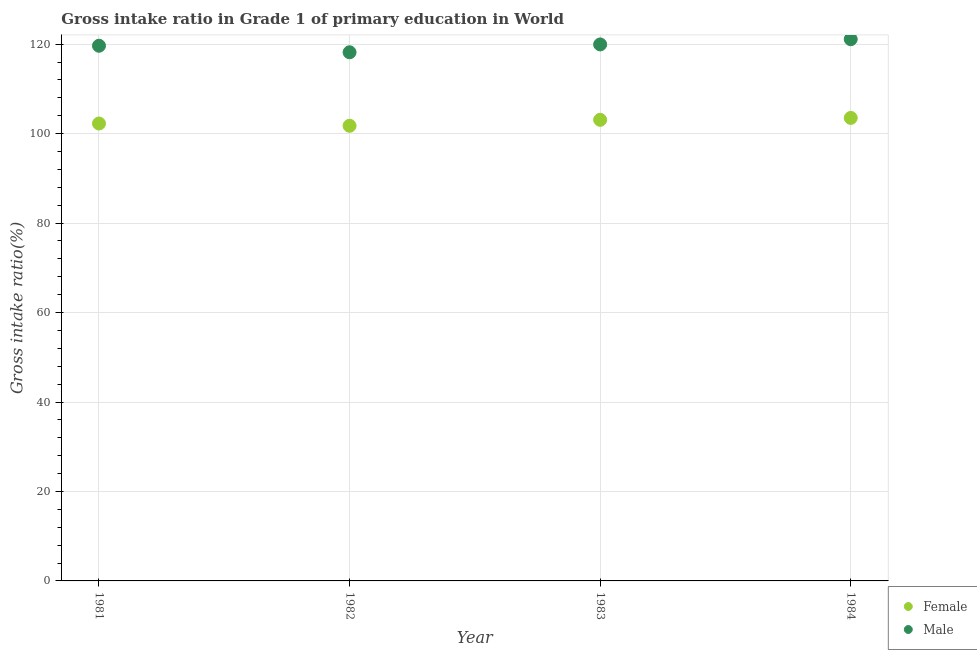Is the number of dotlines equal to the number of legend labels?
Offer a very short reply. Yes. What is the gross intake ratio(male) in 1983?
Your answer should be compact. 119.94. Across all years, what is the maximum gross intake ratio(female)?
Your response must be concise. 103.51. Across all years, what is the minimum gross intake ratio(male)?
Offer a very short reply. 118.19. In which year was the gross intake ratio(female) maximum?
Keep it short and to the point. 1984. What is the total gross intake ratio(male) in the graph?
Make the answer very short. 478.88. What is the difference between the gross intake ratio(female) in 1981 and that in 1983?
Your response must be concise. -0.82. What is the difference between the gross intake ratio(female) in 1983 and the gross intake ratio(male) in 1984?
Offer a terse response. -18.02. What is the average gross intake ratio(female) per year?
Provide a short and direct response. 102.65. In the year 1984, what is the difference between the gross intake ratio(male) and gross intake ratio(female)?
Ensure brevity in your answer.  17.6. In how many years, is the gross intake ratio(male) greater than 100 %?
Your response must be concise. 4. What is the ratio of the gross intake ratio(female) in 1983 to that in 1984?
Give a very brief answer. 1. Is the difference between the gross intake ratio(male) in 1982 and 1984 greater than the difference between the gross intake ratio(female) in 1982 and 1984?
Give a very brief answer. No. What is the difference between the highest and the second highest gross intake ratio(female)?
Make the answer very short. 0.43. What is the difference between the highest and the lowest gross intake ratio(male)?
Ensure brevity in your answer.  2.92. Is the sum of the gross intake ratio(female) in 1982 and 1983 greater than the maximum gross intake ratio(male) across all years?
Keep it short and to the point. Yes. Does the gross intake ratio(male) monotonically increase over the years?
Provide a succinct answer. No. Is the gross intake ratio(male) strictly greater than the gross intake ratio(female) over the years?
Your response must be concise. Yes. Are the values on the major ticks of Y-axis written in scientific E-notation?
Your response must be concise. No. Does the graph contain any zero values?
Offer a terse response. No. Where does the legend appear in the graph?
Offer a very short reply. Bottom right. How many legend labels are there?
Your response must be concise. 2. What is the title of the graph?
Offer a terse response. Gross intake ratio in Grade 1 of primary education in World. Does "Female population" appear as one of the legend labels in the graph?
Give a very brief answer. No. What is the label or title of the Y-axis?
Make the answer very short. Gross intake ratio(%). What is the Gross intake ratio(%) in Female in 1981?
Your response must be concise. 102.26. What is the Gross intake ratio(%) of Male in 1981?
Make the answer very short. 119.65. What is the Gross intake ratio(%) of Female in 1982?
Offer a very short reply. 101.75. What is the Gross intake ratio(%) of Male in 1982?
Provide a short and direct response. 118.19. What is the Gross intake ratio(%) in Female in 1983?
Your response must be concise. 103.09. What is the Gross intake ratio(%) in Male in 1983?
Offer a terse response. 119.94. What is the Gross intake ratio(%) in Female in 1984?
Make the answer very short. 103.51. What is the Gross intake ratio(%) in Male in 1984?
Give a very brief answer. 121.11. Across all years, what is the maximum Gross intake ratio(%) in Female?
Your answer should be compact. 103.51. Across all years, what is the maximum Gross intake ratio(%) in Male?
Your answer should be very brief. 121.11. Across all years, what is the minimum Gross intake ratio(%) of Female?
Provide a short and direct response. 101.75. Across all years, what is the minimum Gross intake ratio(%) in Male?
Provide a short and direct response. 118.19. What is the total Gross intake ratio(%) of Female in the graph?
Ensure brevity in your answer.  410.61. What is the total Gross intake ratio(%) of Male in the graph?
Give a very brief answer. 478.88. What is the difference between the Gross intake ratio(%) in Female in 1981 and that in 1982?
Give a very brief answer. 0.51. What is the difference between the Gross intake ratio(%) in Male in 1981 and that in 1982?
Give a very brief answer. 1.46. What is the difference between the Gross intake ratio(%) of Female in 1981 and that in 1983?
Offer a terse response. -0.82. What is the difference between the Gross intake ratio(%) of Male in 1981 and that in 1983?
Make the answer very short. -0.3. What is the difference between the Gross intake ratio(%) of Female in 1981 and that in 1984?
Offer a very short reply. -1.25. What is the difference between the Gross intake ratio(%) of Male in 1981 and that in 1984?
Offer a terse response. -1.46. What is the difference between the Gross intake ratio(%) of Female in 1982 and that in 1983?
Your answer should be compact. -1.33. What is the difference between the Gross intake ratio(%) of Male in 1982 and that in 1983?
Keep it short and to the point. -1.75. What is the difference between the Gross intake ratio(%) in Female in 1982 and that in 1984?
Your response must be concise. -1.76. What is the difference between the Gross intake ratio(%) of Male in 1982 and that in 1984?
Make the answer very short. -2.92. What is the difference between the Gross intake ratio(%) in Female in 1983 and that in 1984?
Give a very brief answer. -0.43. What is the difference between the Gross intake ratio(%) of Male in 1983 and that in 1984?
Provide a succinct answer. -1.17. What is the difference between the Gross intake ratio(%) in Female in 1981 and the Gross intake ratio(%) in Male in 1982?
Your response must be concise. -15.93. What is the difference between the Gross intake ratio(%) of Female in 1981 and the Gross intake ratio(%) of Male in 1983?
Offer a very short reply. -17.68. What is the difference between the Gross intake ratio(%) in Female in 1981 and the Gross intake ratio(%) in Male in 1984?
Give a very brief answer. -18.85. What is the difference between the Gross intake ratio(%) of Female in 1982 and the Gross intake ratio(%) of Male in 1983?
Give a very brief answer. -18.19. What is the difference between the Gross intake ratio(%) of Female in 1982 and the Gross intake ratio(%) of Male in 1984?
Offer a terse response. -19.36. What is the difference between the Gross intake ratio(%) of Female in 1983 and the Gross intake ratio(%) of Male in 1984?
Your response must be concise. -18.02. What is the average Gross intake ratio(%) in Female per year?
Provide a succinct answer. 102.65. What is the average Gross intake ratio(%) in Male per year?
Offer a very short reply. 119.72. In the year 1981, what is the difference between the Gross intake ratio(%) in Female and Gross intake ratio(%) in Male?
Offer a very short reply. -17.38. In the year 1982, what is the difference between the Gross intake ratio(%) of Female and Gross intake ratio(%) of Male?
Provide a short and direct response. -16.44. In the year 1983, what is the difference between the Gross intake ratio(%) of Female and Gross intake ratio(%) of Male?
Your response must be concise. -16.86. In the year 1984, what is the difference between the Gross intake ratio(%) of Female and Gross intake ratio(%) of Male?
Give a very brief answer. -17.6. What is the ratio of the Gross intake ratio(%) of Male in 1981 to that in 1982?
Provide a succinct answer. 1.01. What is the ratio of the Gross intake ratio(%) of Male in 1981 to that in 1983?
Ensure brevity in your answer.  1. What is the ratio of the Gross intake ratio(%) of Female in 1981 to that in 1984?
Your answer should be compact. 0.99. What is the ratio of the Gross intake ratio(%) of Male in 1981 to that in 1984?
Offer a very short reply. 0.99. What is the ratio of the Gross intake ratio(%) in Female in 1982 to that in 1983?
Keep it short and to the point. 0.99. What is the ratio of the Gross intake ratio(%) in Male in 1982 to that in 1983?
Ensure brevity in your answer.  0.99. What is the ratio of the Gross intake ratio(%) in Male in 1982 to that in 1984?
Your response must be concise. 0.98. What is the ratio of the Gross intake ratio(%) of Female in 1983 to that in 1984?
Provide a succinct answer. 1. What is the ratio of the Gross intake ratio(%) in Male in 1983 to that in 1984?
Your response must be concise. 0.99. What is the difference between the highest and the second highest Gross intake ratio(%) in Female?
Your answer should be compact. 0.43. What is the difference between the highest and the second highest Gross intake ratio(%) of Male?
Your response must be concise. 1.17. What is the difference between the highest and the lowest Gross intake ratio(%) of Female?
Your answer should be compact. 1.76. What is the difference between the highest and the lowest Gross intake ratio(%) of Male?
Offer a very short reply. 2.92. 